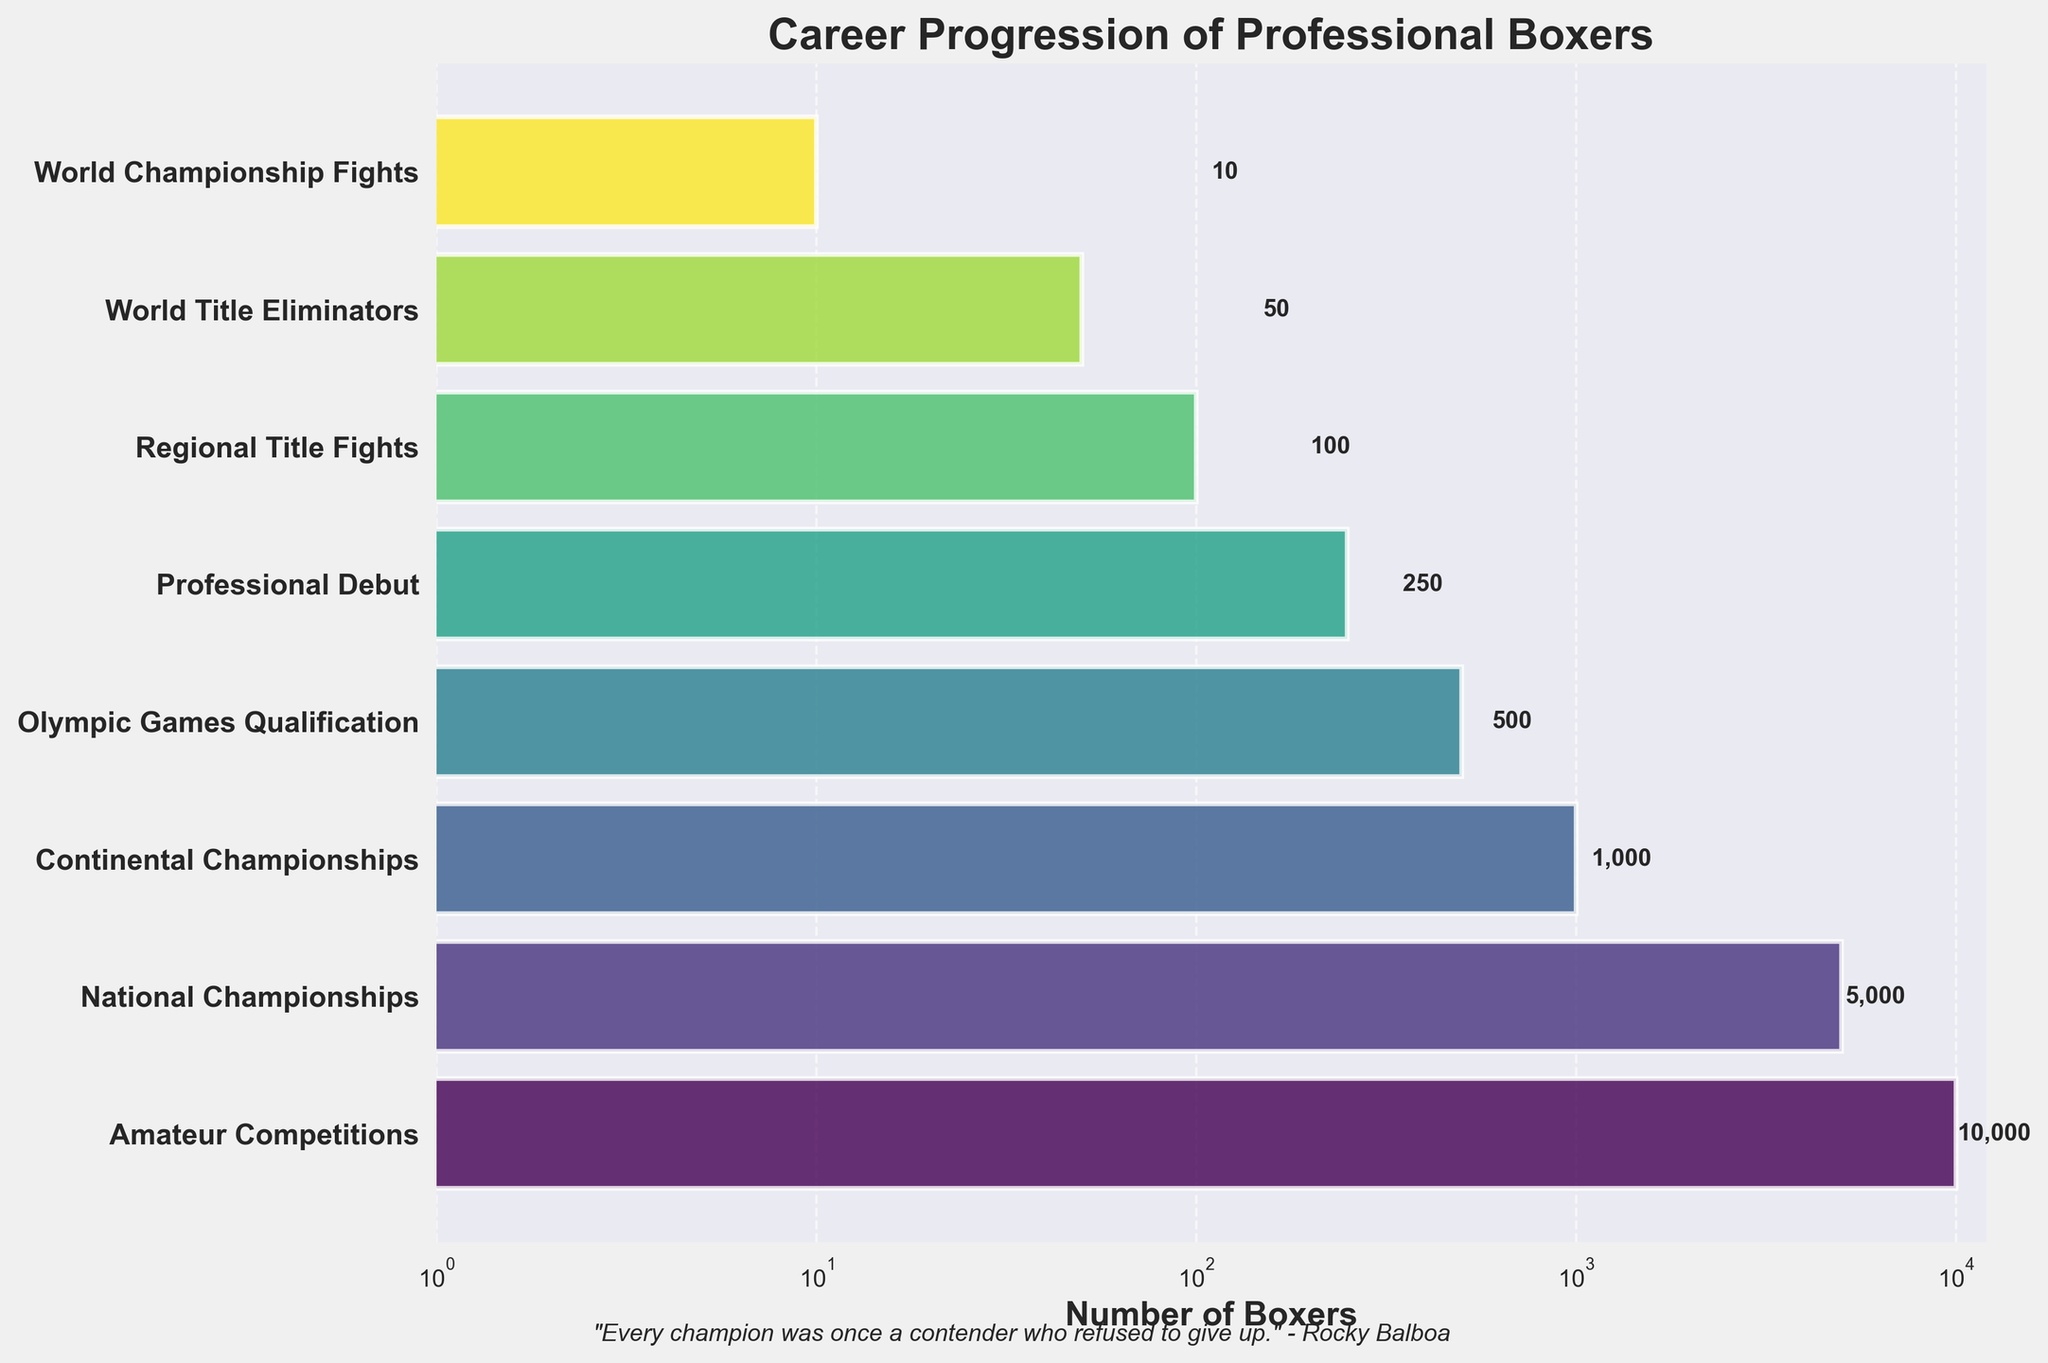What's the title of the plot? The title of the plot is usually located at the top. According to the code, the title is set to "Career Progression of Professional Boxers."
Answer: Career Progression of Professional Boxers Which stage has the highest number of boxers? The stage with the largest bar represents the highest number of boxers. From the plot, we can see that "Amateur Competitions" has the highest bar.
Answer: Amateur Competitions What's the number of boxers in Regional Title Fights? Looking at the value labels next to the bars, the "Regional Title Fights" stage has a label showing "100".
Answer: 100 What’s the difference in the number of boxers between Olympic Games Qualification and National Championships? From the labels, "Olympic Games Qualification" has 500 boxers, and "National Championships" has 5000. The difference is 5000 - 500.
Answer: 4500 By how much does the number of boxers decrease from Amateur Competitions to Continental Championships? "Amateur Competitions" stage has 10000 boxers and "Continental Championships" stage has 1000 boxers. The decrease is 10000 - 1000.
Answer: 9000 Which stage has fewer boxers, Professional Debut or World Title Eliminators? Comparing the bars and labels of "Professional Debut" (250) and "World Title Eliminators" (50), "World Title Eliminators" has fewer boxers.
Answer: World Title Eliminators How many stages are represented in the plot? Count the number of bars or labels on the y-axis. The plot represents 8 stages.
Answer: 8 How does the number of boxers in World Championship Fights compare to those in Continental Championships? The bar for "World Championship Fights" shows 10 boxers, and "Continental Championships" shows 1000 boxers. The number of boxers in "World Championship Fights" is significantly lower.
Answer: Significantly lower What's the trend observed in the number of boxers as they advance through the stages? By observing the lengths of the bars, we see that the number of boxers decreases as they progress through the stages from amateur to professional levels.
Answer: Decreasing trend 